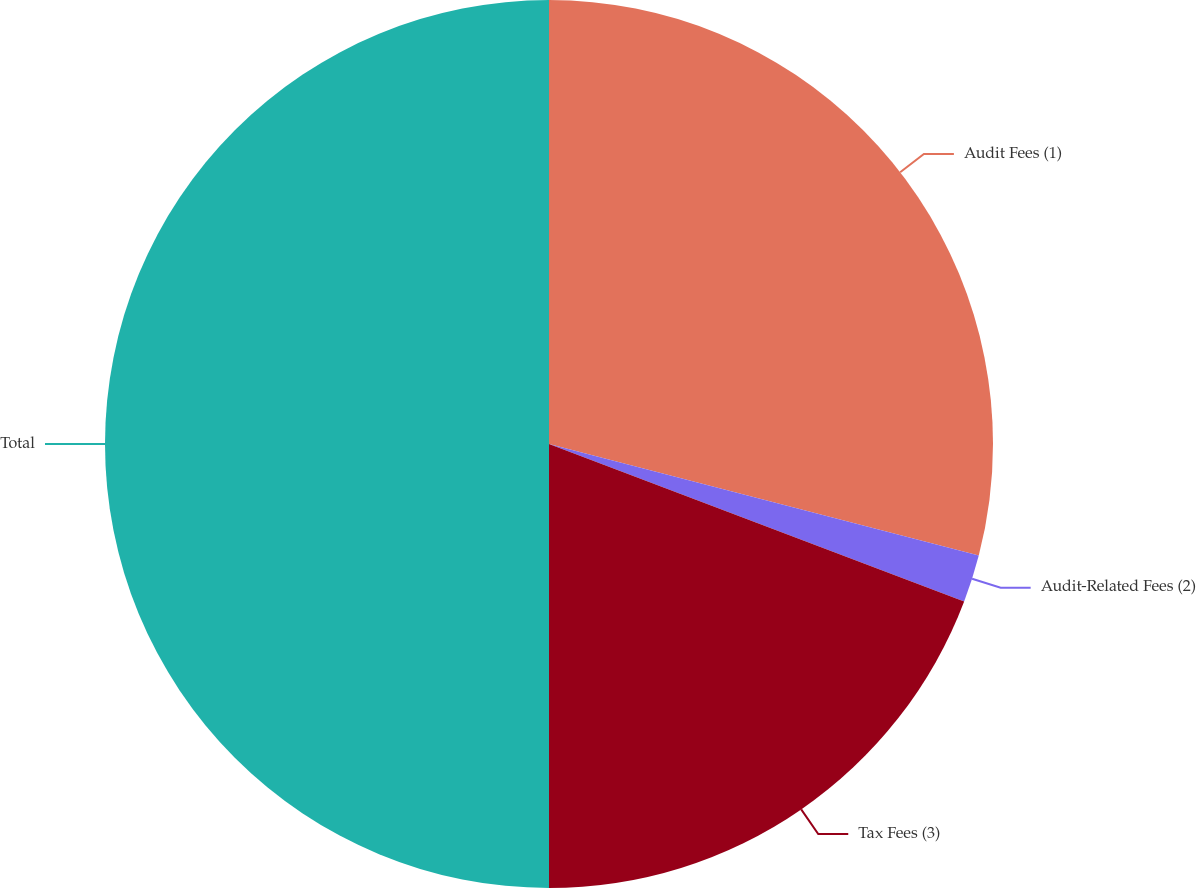Convert chart. <chart><loc_0><loc_0><loc_500><loc_500><pie_chart><fcel>Audit Fees (1)<fcel>Audit-Related Fees (2)<fcel>Tax Fees (3)<fcel>Total<nl><fcel>29.04%<fcel>1.73%<fcel>19.23%<fcel>50.0%<nl></chart> 